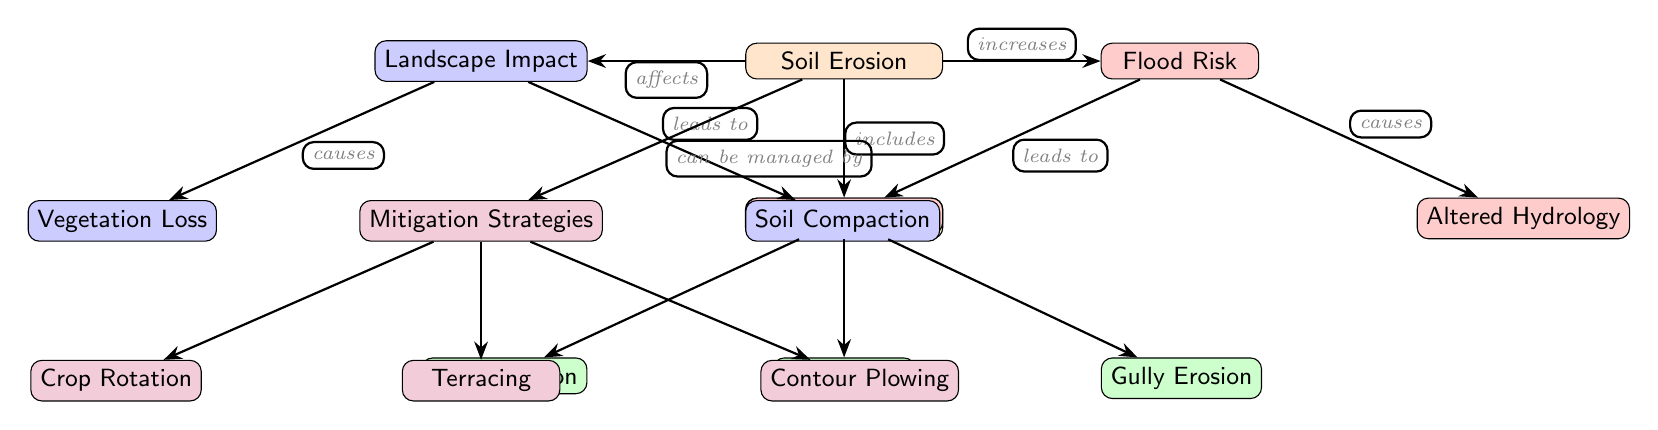What are the types of erosion listed in the diagram? The diagram lists three types of erosion: Sheet Erosion, Rill Erosion, and Gully Erosion, which can all be found under the "Types of Erosion" node.
Answer: Sheet Erosion, Rill Erosion, Gully Erosion What does soil erosion increase? According to the diagram, soil erosion increases flood risk, as indicated by the arrow labeled "increases" leading from "Soil Erosion" to "Flood Risk".
Answer: Flood Risk How many nodes represent impacts related to landscape? There are two nodes that represent impacts related to the landscape: Vegetation Loss and Soil Compaction, which are found under the "Landscape Impact" node.
Answer: 2 What causes increased runoff according to the diagram? The diagram states that increased runoff is a consequence of flood risk, as shown by the arrow labeled "leads to" from "Flood Risk" to "Increased Runoff".
Answer: Flood Risk Which mitigation strategy is mentioned last in the diagram? The last mitigation strategy listed in the diagram is Contour Plowing, which is the rightmost node under the "Mitigation Strategies".
Answer: Contour Plowing What are the relationships between landscape impact and soil erosion? The diagram illustrates that soil erosion affects landscape impact, which is depicted by the edge labeled "affects" leading from "Soil Erosion" to "Landscape Impact". This impact then leads to two outcomes: vegetation loss and soil compaction.
Answer: Affects, causes What different types of erosion affect flood risk? The types of erosion listed in the diagram include Sheet Erosion, Rill Erosion, and Gully Erosion, all of which are part of the soil erosion process that increases flood risk.
Answer: Sheet Erosion, Rill Erosion, Gully Erosion What is a consequence of soil compaction according to this diagram? The diagram shows that soil compaction is a consequence of landscape impact, which is indicated by the arrow labeled "leads to" showing the relationship between "Landscape Impact" and "Soil Compaction".
Answer: Soil Compaction 